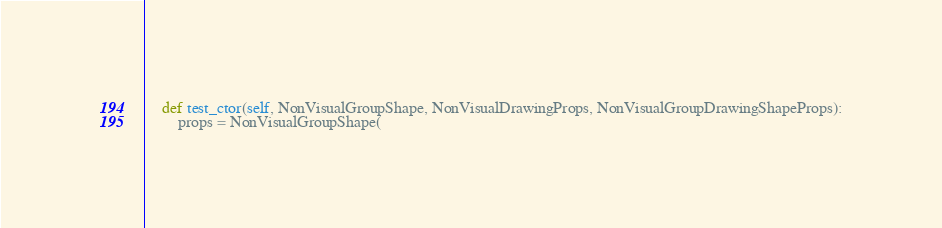Convert code to text. <code><loc_0><loc_0><loc_500><loc_500><_Python_>

    def test_ctor(self, NonVisualGroupShape, NonVisualDrawingProps, NonVisualGroupDrawingShapeProps):
        props = NonVisualGroupShape(</code> 